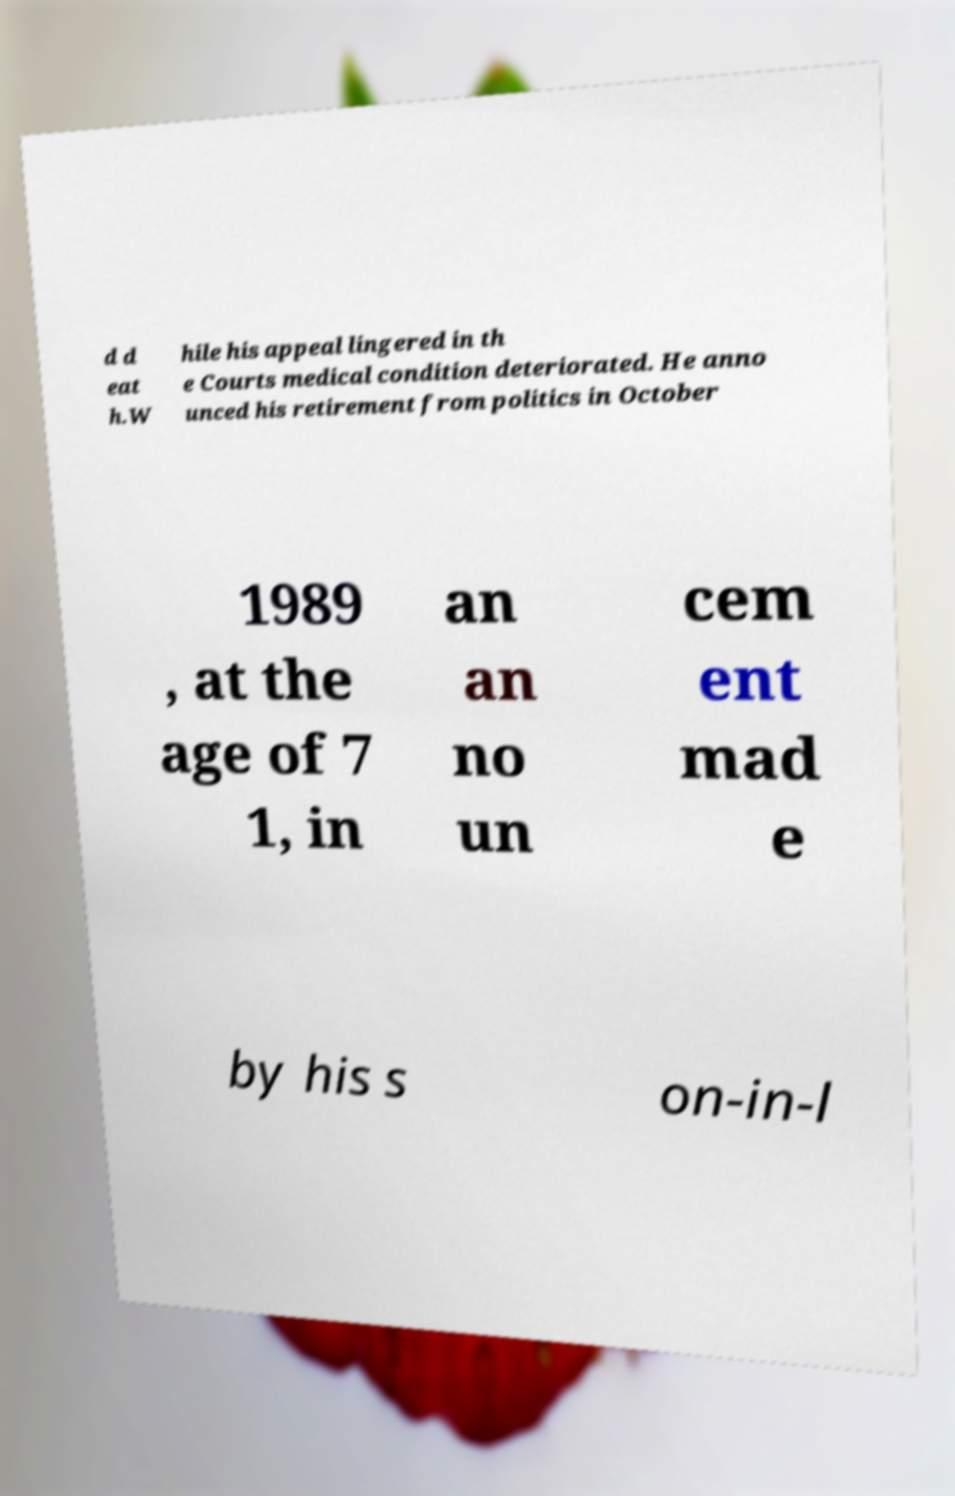What messages or text are displayed in this image? I need them in a readable, typed format. d d eat h.W hile his appeal lingered in th e Courts medical condition deteriorated. He anno unced his retirement from politics in October 1989 , at the age of 7 1, in an an no un cem ent mad e by his s on-in-l 